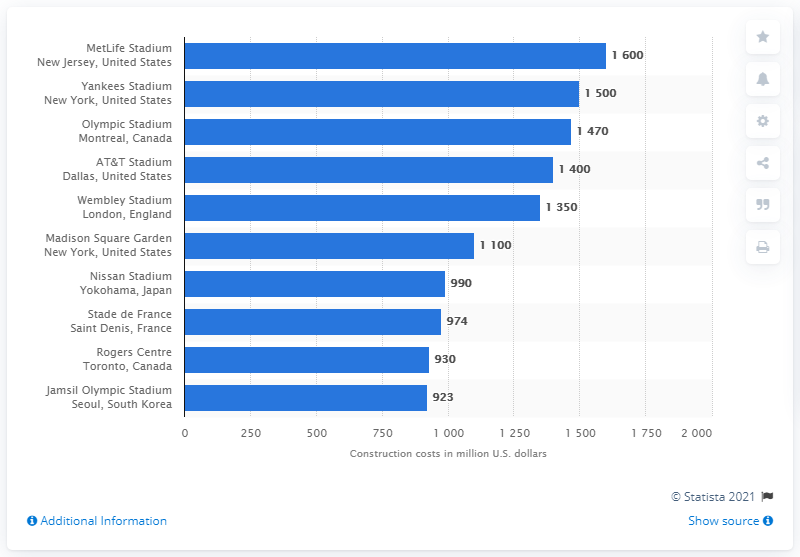Point out several critical features in this image. The cost to build MetLife Stadium was approximately $1600 million. The least number in the chart is 923. The average of the highest and lowest numbers in the chart is 1261.5. 